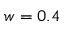Convert formula to latex. <formula><loc_0><loc_0><loc_500><loc_500>w = 0 . 4</formula> 